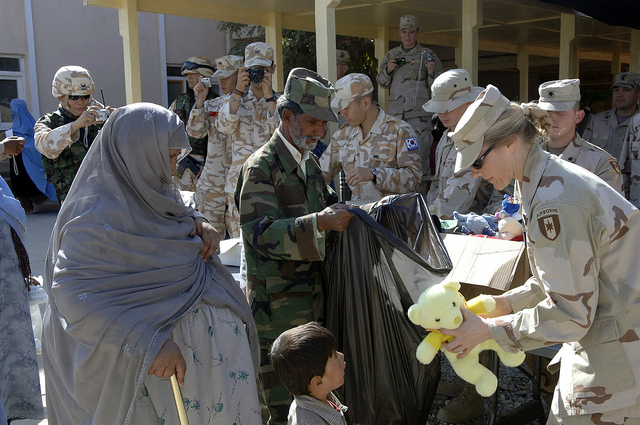Describe a possible backstory for this scene. The scene likely takes place in a region affected by conflict or natural disaster, where military personnel have been deployed to provide humanitarian assistance. The soldiers might be part of a peacekeeping mission or a specialized unit dedicated to aiding civilians. The presence of women and children suggests that civilians are the primary beneficiaries of this aid operation. The large bags and boxes of supplies indicate a well-organized effort to distribute necessary items such as food, clothing, and toys. The event is probably one of many similar initiatives aimed at supporting the local population and building positive relations. If you could imagine a story for one of the children receiving a teddy bear, what would it be? Imagine a small boy named Ali who has lived in a tough and war-torn environment for most of his young life. Despite the challenges, Ali maintains a cheerful spirit and a hopeful heart. On this particular day, he is thrilled to receive a teddy bear from one of the soldiers. Holding the bear tightly, Ali imagines it as a magical guardian that will protect him and his family. Each night, the teddy bear becomes his confidant and comfort, helping him dream of a brighter and peaceful future. This precious moment, and the kindness shown by the soldiers, inspires Ali to aspire to be someone who helps others when he grows up. Could you create a poetic description about the scene? In a courtyard where shadows blend with hope,
Soldiers don camouflaged threads, each a gentle slope.
With laden hearts, they bear gifts and smiles,
To soften life's burdens, though just for a while.
Children’s eyes gleam at the sight of love's token,
A teddy bear's hug, promises unspoken.
Women in headscarves, weary yet proud,
Stand side by side with the uniformed crowd.
In the dance of giving, amidst war's weary race,
Compassion finds its rhythm, and humanity its grace. 